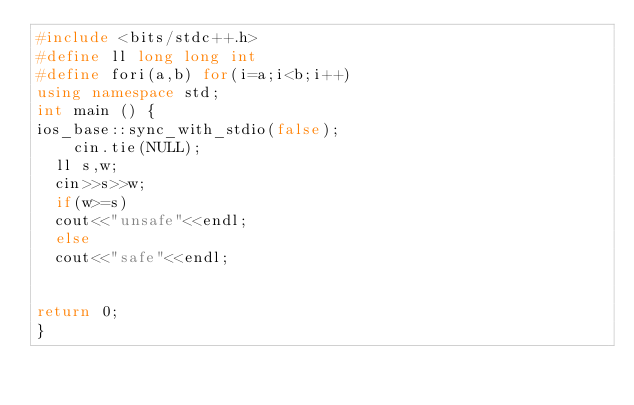Convert code to text. <code><loc_0><loc_0><loc_500><loc_500><_C++_>#include <bits/stdc++.h>
#define ll long long int
#define fori(a,b) for(i=a;i<b;i++)
using namespace std;
int main () {
ios_base::sync_with_stdio(false);
    cin.tie(NULL);
  ll s,w;
  cin>>s>>w;
  if(w>=s)
  cout<<"unsafe"<<endl;
  else
  cout<<"safe"<<endl;
  

return 0;
}
</code> 